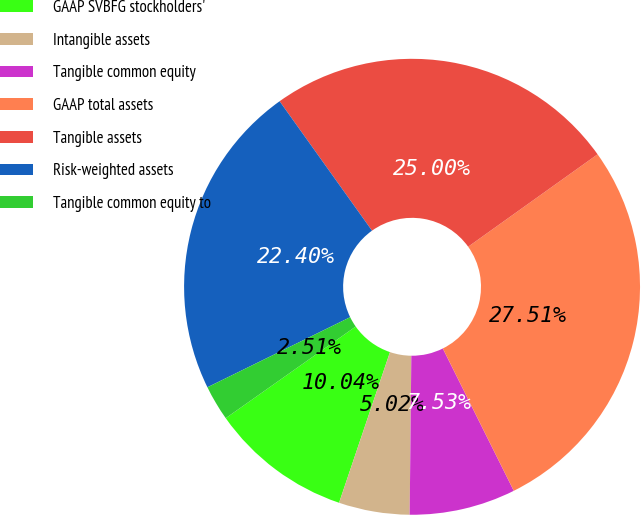Convert chart to OTSL. <chart><loc_0><loc_0><loc_500><loc_500><pie_chart><fcel>GAAP SVBFG stockholders'<fcel>Intangible assets<fcel>Tangible common equity<fcel>GAAP total assets<fcel>Tangible assets<fcel>Risk-weighted assets<fcel>Tangible common equity to<nl><fcel>10.04%<fcel>5.02%<fcel>7.53%<fcel>27.51%<fcel>25.0%<fcel>22.4%<fcel>2.51%<nl></chart> 